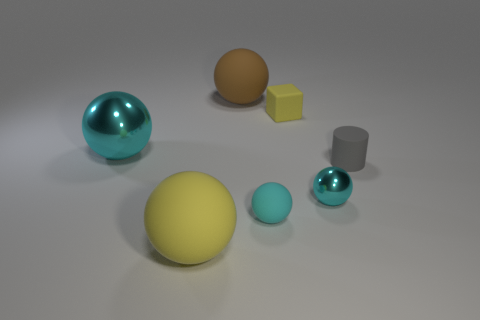Does the small rubber block have the same color as the small metal thing?
Provide a succinct answer. No. What size is the ball that is the same color as the block?
Provide a short and direct response. Large. What number of other things are the same size as the yellow rubber ball?
Ensure brevity in your answer.  2. The rubber ball that is behind the cyan metallic object behind the small matte object right of the yellow block is what color?
Ensure brevity in your answer.  Brown. The rubber thing that is both in front of the large brown object and on the left side of the tiny cyan matte thing has what shape?
Offer a very short reply. Sphere. What number of other things are there of the same shape as the gray rubber thing?
Provide a succinct answer. 0. There is a cyan metallic object that is behind the cyan metal sphere right of the matte object that is in front of the small cyan rubber sphere; what shape is it?
Keep it short and to the point. Sphere. How many objects are small rubber objects or big objects that are in front of the small yellow object?
Your answer should be compact. 5. Do the yellow thing behind the tiny cyan rubber object and the cyan metal object behind the gray cylinder have the same shape?
Give a very brief answer. No. How many things are either big purple balls or cyan shiny objects?
Your answer should be compact. 2. 